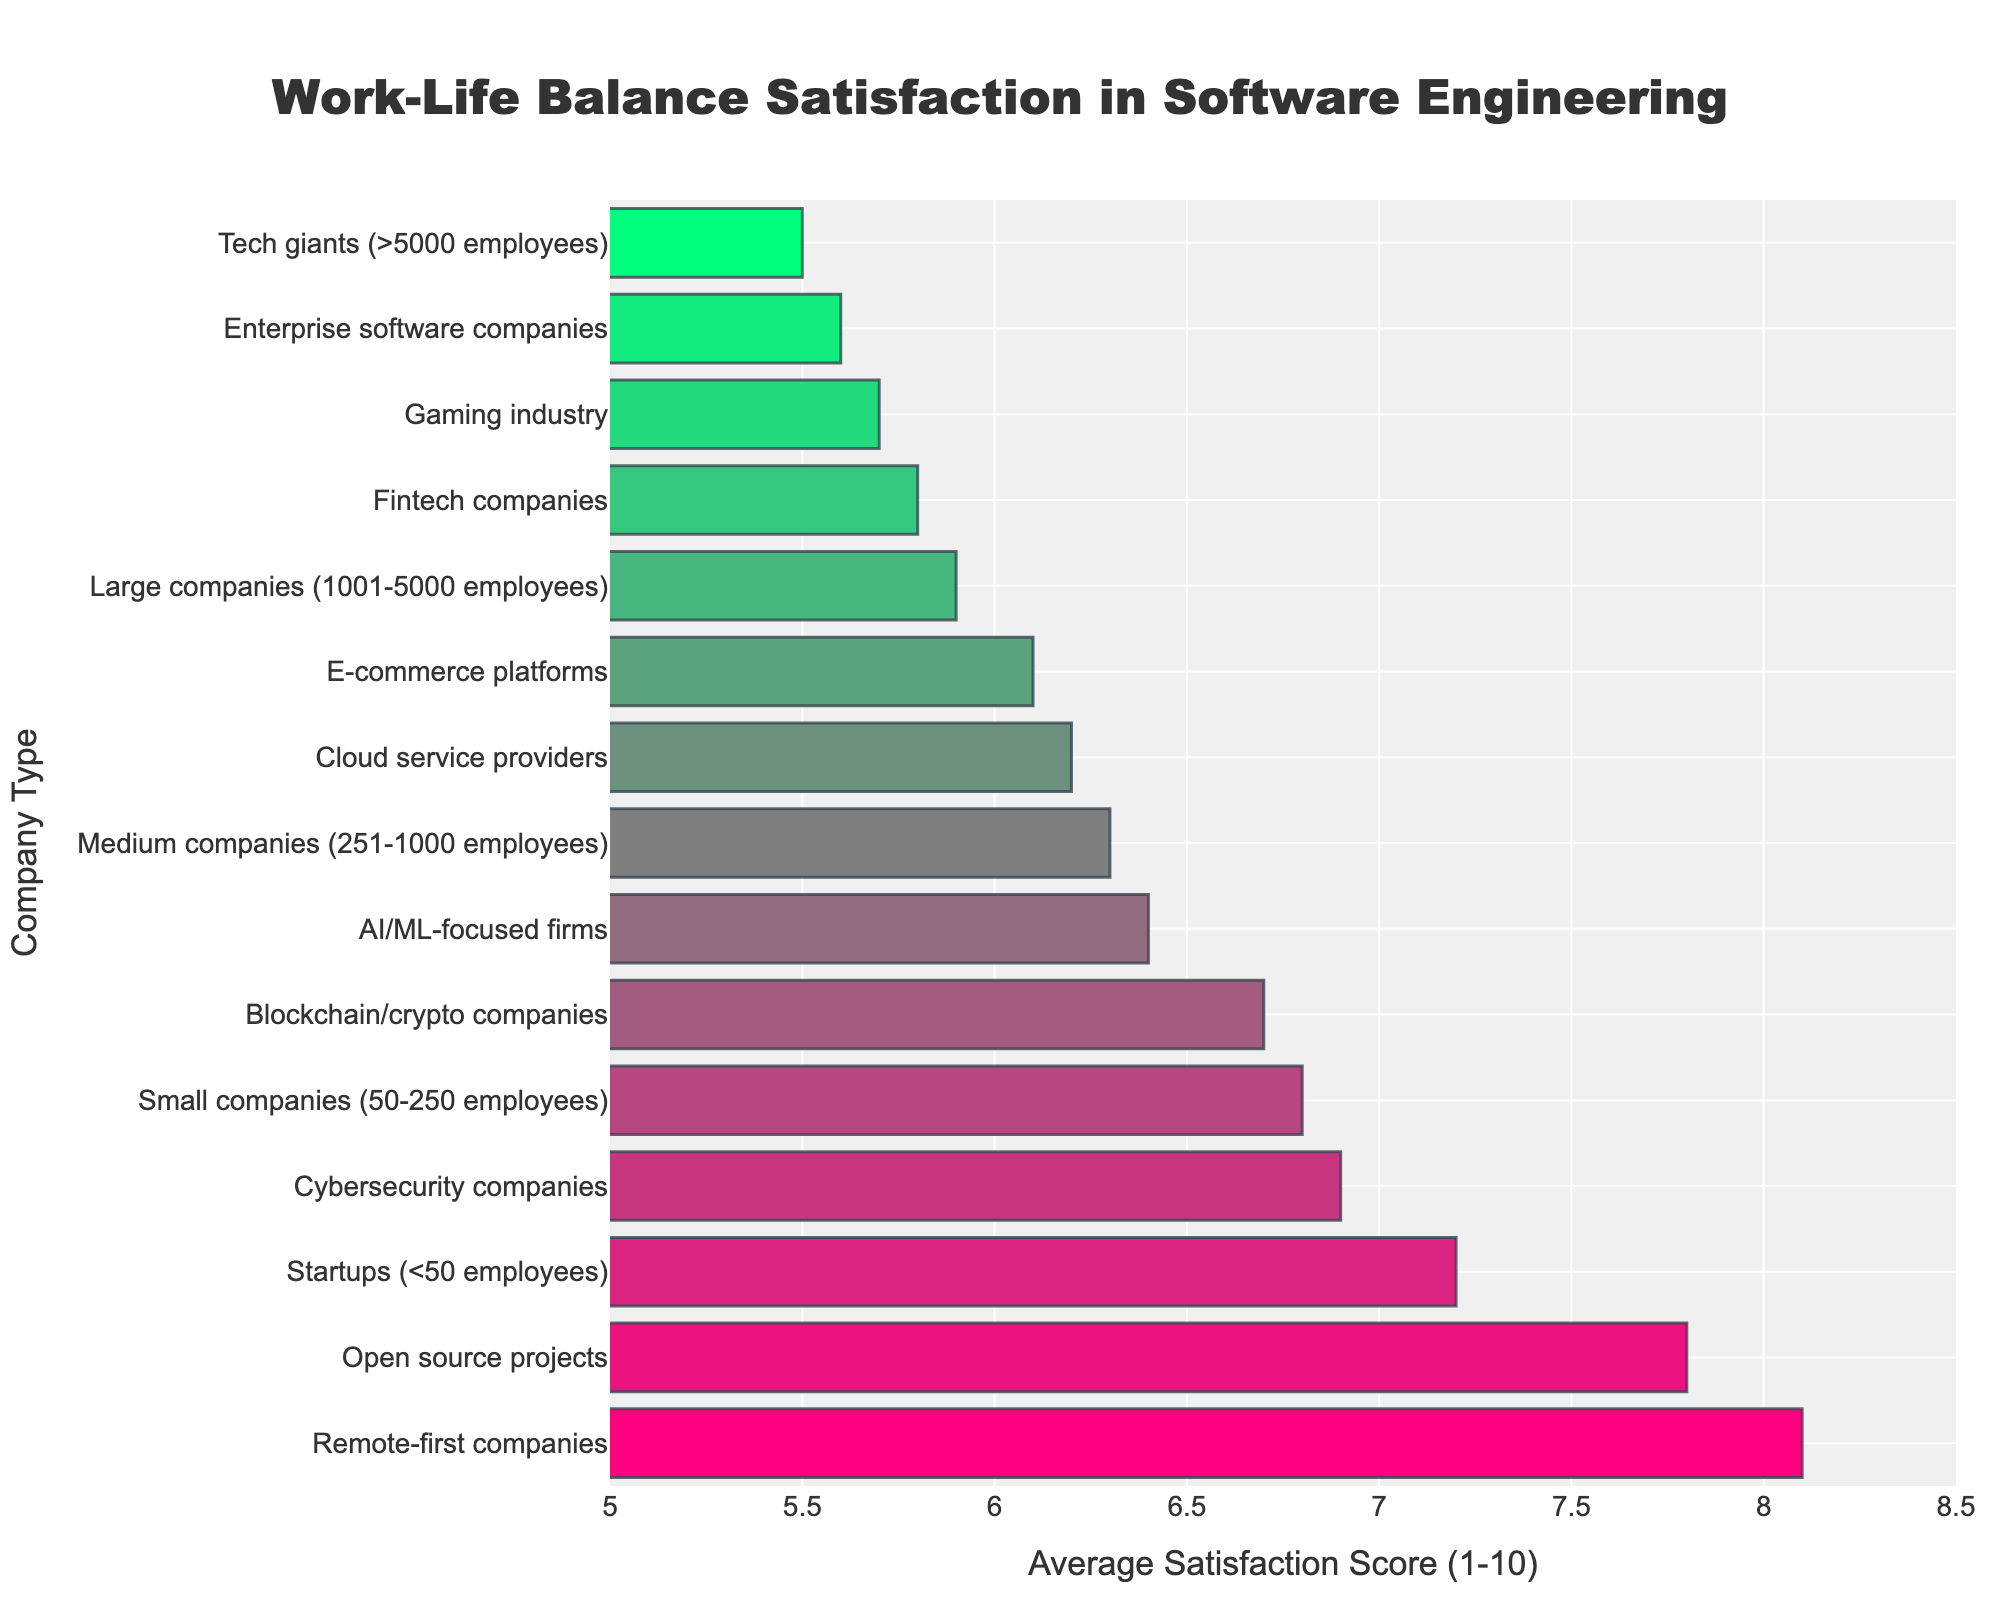Which company type has the highest work-life balance satisfaction score? Identify the company type with the highest bar on the chart. The highest bar represents the highest satisfaction score. The longest bar corresponds to "Remote-first companies" with a score of 8.1.
Answer: Remote-first companies Which company type has the lowest work-life balance satisfaction score? Identify the company type with the lowest bar on the chart. The lowest bar represents the lowest satisfaction score. The shortest bar corresponds to "Tech giants" with a score of 5.5.
Answer: Tech giants How does the satisfaction score of small companies compare to that of medium companies? Find the bars corresponding to small and medium companies. Compare their lengths and corresponding values. Small companies have a score of 6.8, while medium companies have a score of 6.3. Small companies have a higher satisfaction score.
Answer: Small companies have a higher satisfaction score What is the difference in satisfaction scores between startups and cybersecurity companies? Identify the bars for startups and cybersecurity companies. Subtract the satisfaction score of cybersecurity companies from that of startups (7.2 - 6.9).
Answer: 0.3 Which companies have satisfaction scores below 6? Find all bars with satisfaction scores below the 6 value on the x-axis. These bars are for "Large companies," "Tech giants," "Gaming industry," "Fintech companies," and "Enterprise software companies."
Answer: Large companies, Tech giants, Gaming industry, Fintech companies, Enterprise software companies What is the average satisfaction score of companies focused on AI/ML, gaming, and fintech? Identify the bars for AI/ML-focused firms, gaming industry, and fintech companies. Sum their scores (6.4 + 5.7 + 5.8) and divide by the number of companies (3).
Answer: 5.97 Which company types have a satisfaction score greater than 7? Find all bars with satisfaction scores above the 7 value on the x-axis. These bars represent "Remote-first companies," "Open source projects," and "Startups."
Answer: Remote-first companies, Open source projects, Startups How does the satisfaction score of e-commerce platforms compare to the average satisfaction score of all companies? Calculate the average satisfaction score of all companies by summing all the scores and dividing by the number of companies. Compare the satisfaction score of e-commerce platforms (6.1) with the calculated average. The average satisfaction score is 6.46, so e-commerce platforms have a lower satisfaction score.
Answer: E-commerce platforms have a lower satisfaction score What is the range of satisfaction scores among all company types? Identify the highest and lowest satisfaction scores from the chart, and subtract the lowest score from the highest (8.1 - 5.5).
Answer: 2.6 How do cloud service providers' satisfaction scores compare to fintech companies? Find the bars corresponding to cloud service providers and fintech companies. Compare their lengths and corresponding values. Cloud service providers have a score of 6.2, while fintech companies have a score of 5.8. Cloud service providers have a higher satisfaction score.
Answer: Cloud service providers have a higher satisfaction score 